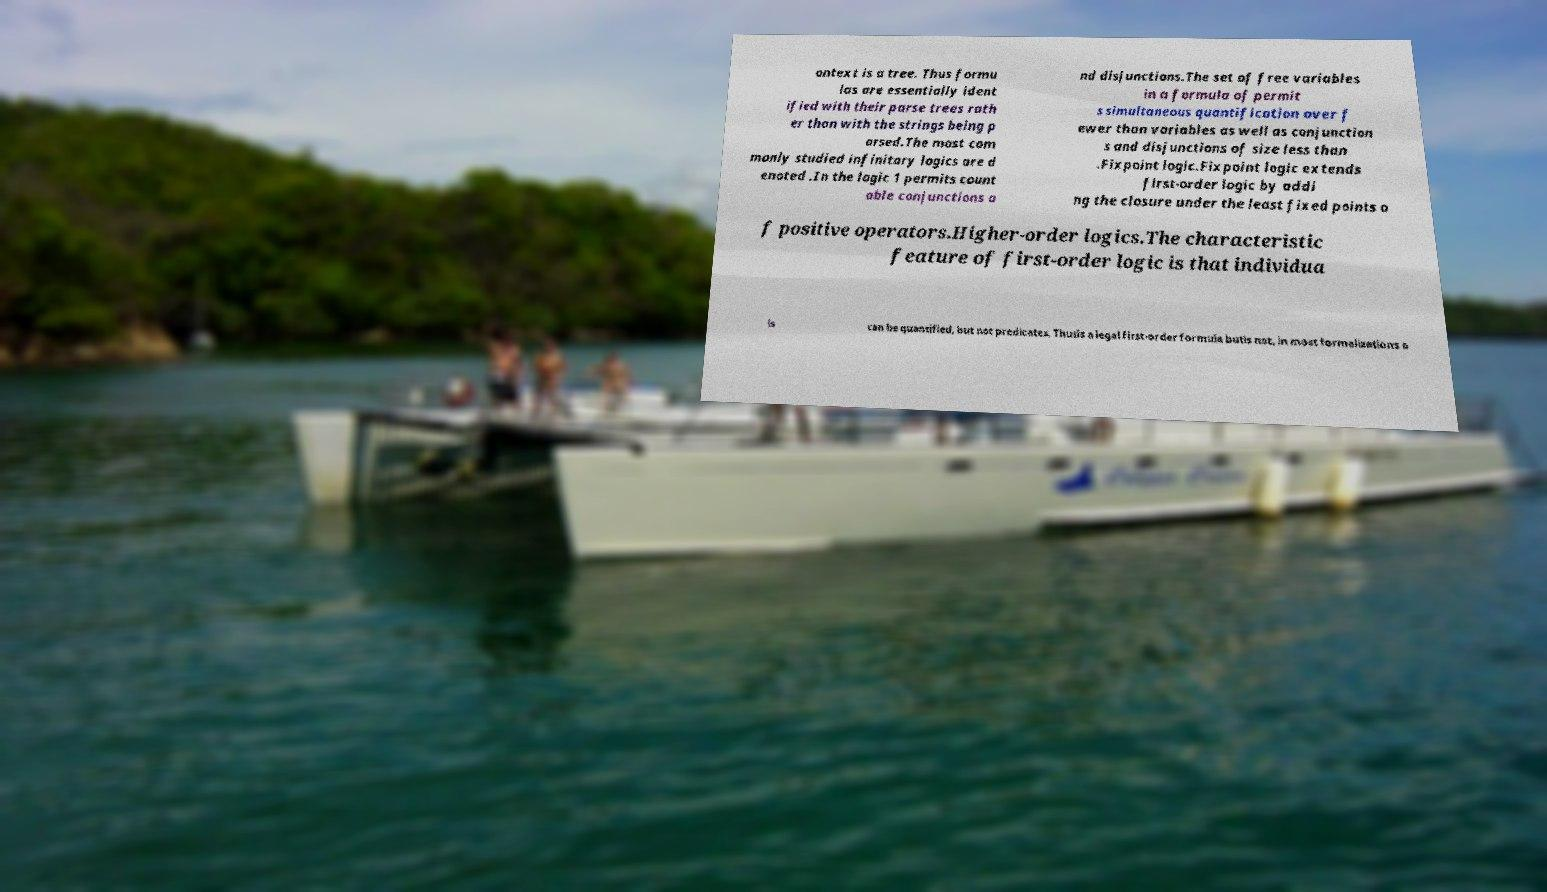Can you read and provide the text displayed in the image?This photo seems to have some interesting text. Can you extract and type it out for me? ontext is a tree. Thus formu las are essentially ident ified with their parse trees rath er than with the strings being p arsed.The most com monly studied infinitary logics are d enoted .In the logic 1 permits count able conjunctions a nd disjunctions.The set of free variables in a formula of permit s simultaneous quantification over f ewer than variables as well as conjunction s and disjunctions of size less than .Fixpoint logic.Fixpoint logic extends first-order logic by addi ng the closure under the least fixed points o f positive operators.Higher-order logics.The characteristic feature of first-order logic is that individua ls can be quantified, but not predicates. Thusis a legal first-order formula butis not, in most formalizations o 